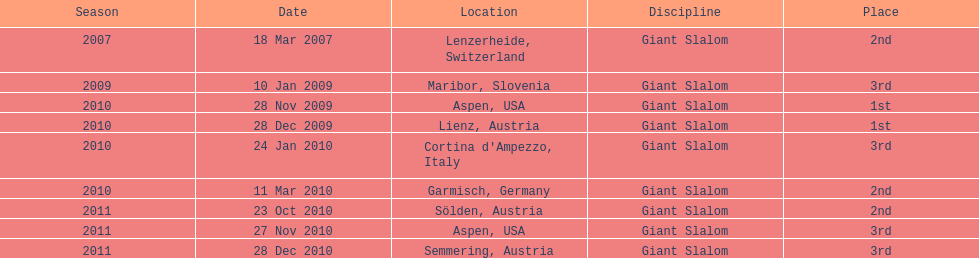Can you give me this table as a dict? {'header': ['Season', 'Date', 'Location', 'Discipline', 'Place'], 'rows': [['2007', '18 Mar 2007', 'Lenzerheide, Switzerland', 'Giant Slalom', '2nd'], ['2009', '10 Jan 2009', 'Maribor, Slovenia', 'Giant Slalom', '3rd'], ['2010', '28 Nov 2009', 'Aspen, USA', 'Giant Slalom', '1st'], ['2010', '28 Dec 2009', 'Lienz, Austria', 'Giant Slalom', '1st'], ['2010', '24 Jan 2010', "Cortina d'Ampezzo, Italy", 'Giant Slalom', '3rd'], ['2010', '11 Mar 2010', 'Garmisch, Germany', 'Giant Slalom', '2nd'], ['2011', '23 Oct 2010', 'Sölden, Austria', 'Giant Slalom', '2nd'], ['2011', '27 Nov 2010', 'Aspen, USA', 'Giant Slalom', '3rd'], ['2011', '28 Dec 2010', 'Semmering, Austria', 'Giant Slalom', '3rd']]} In 2010, what was the total number of races? 5. 